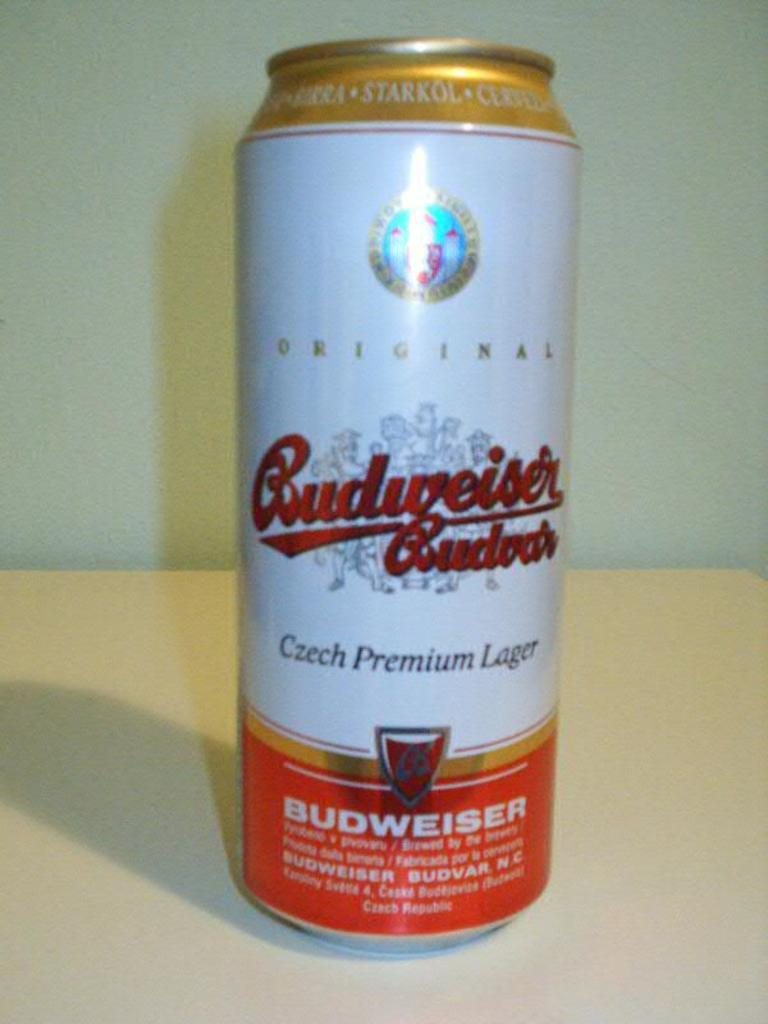What object is placed on the wooden table in the image? There is a beverage can in the image, and it is placed on a wooden table. What is the material of the table in the image? The table in the image is made of wood. What can be found on the beverage can besides the writing? There is a symbol on the beverage can. What color is the backdrop of the image? The backdrop of the image is a white color wall. How many slaves are depicted in the image? There are no slaves depicted in the image; it features a beverage can on a wooden table with a white color wall as the backdrop. What type of goose can be seen in the image? There is no goose present in the image. 